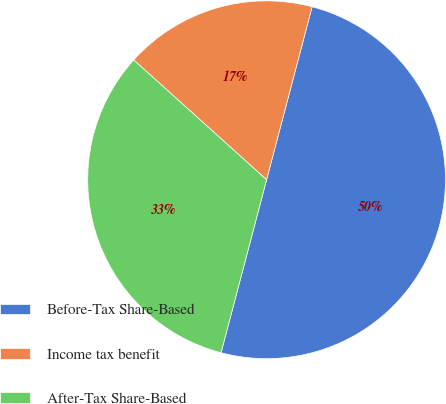<chart> <loc_0><loc_0><loc_500><loc_500><pie_chart><fcel>Before-Tax Share-Based<fcel>Income tax benefit<fcel>After-Tax Share-Based<nl><fcel>50.0%<fcel>17.42%<fcel>32.58%<nl></chart> 